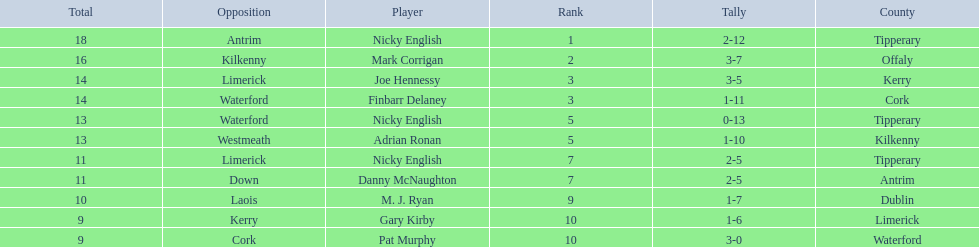Who are all the players? Nicky English, Mark Corrigan, Joe Hennessy, Finbarr Delaney, Nicky English, Adrian Ronan, Nicky English, Danny McNaughton, M. J. Ryan, Gary Kirby, Pat Murphy. How many points did they receive? 18, 16, 14, 14, 13, 13, 11, 11, 10, 9, 9. Parse the full table. {'header': ['Total', 'Opposition', 'Player', 'Rank', 'Tally', 'County'], 'rows': [['18', 'Antrim', 'Nicky English', '1', '2-12', 'Tipperary'], ['16', 'Kilkenny', 'Mark Corrigan', '2', '3-7', 'Offaly'], ['14', 'Limerick', 'Joe Hennessy', '3', '3-5', 'Kerry'], ['14', 'Waterford', 'Finbarr Delaney', '3', '1-11', 'Cork'], ['13', 'Waterford', 'Nicky English', '5', '0-13', 'Tipperary'], ['13', 'Westmeath', 'Adrian Ronan', '5', '1-10', 'Kilkenny'], ['11', 'Limerick', 'Nicky English', '7', '2-5', 'Tipperary'], ['11', 'Down', 'Danny McNaughton', '7', '2-5', 'Antrim'], ['10', 'Laois', 'M. J. Ryan', '9', '1-7', 'Dublin'], ['9', 'Kerry', 'Gary Kirby', '10', '1-6', 'Limerick'], ['9', 'Cork', 'Pat Murphy', '10', '3-0', 'Waterford']]} And which player received 10 points? M. J. Ryan. 